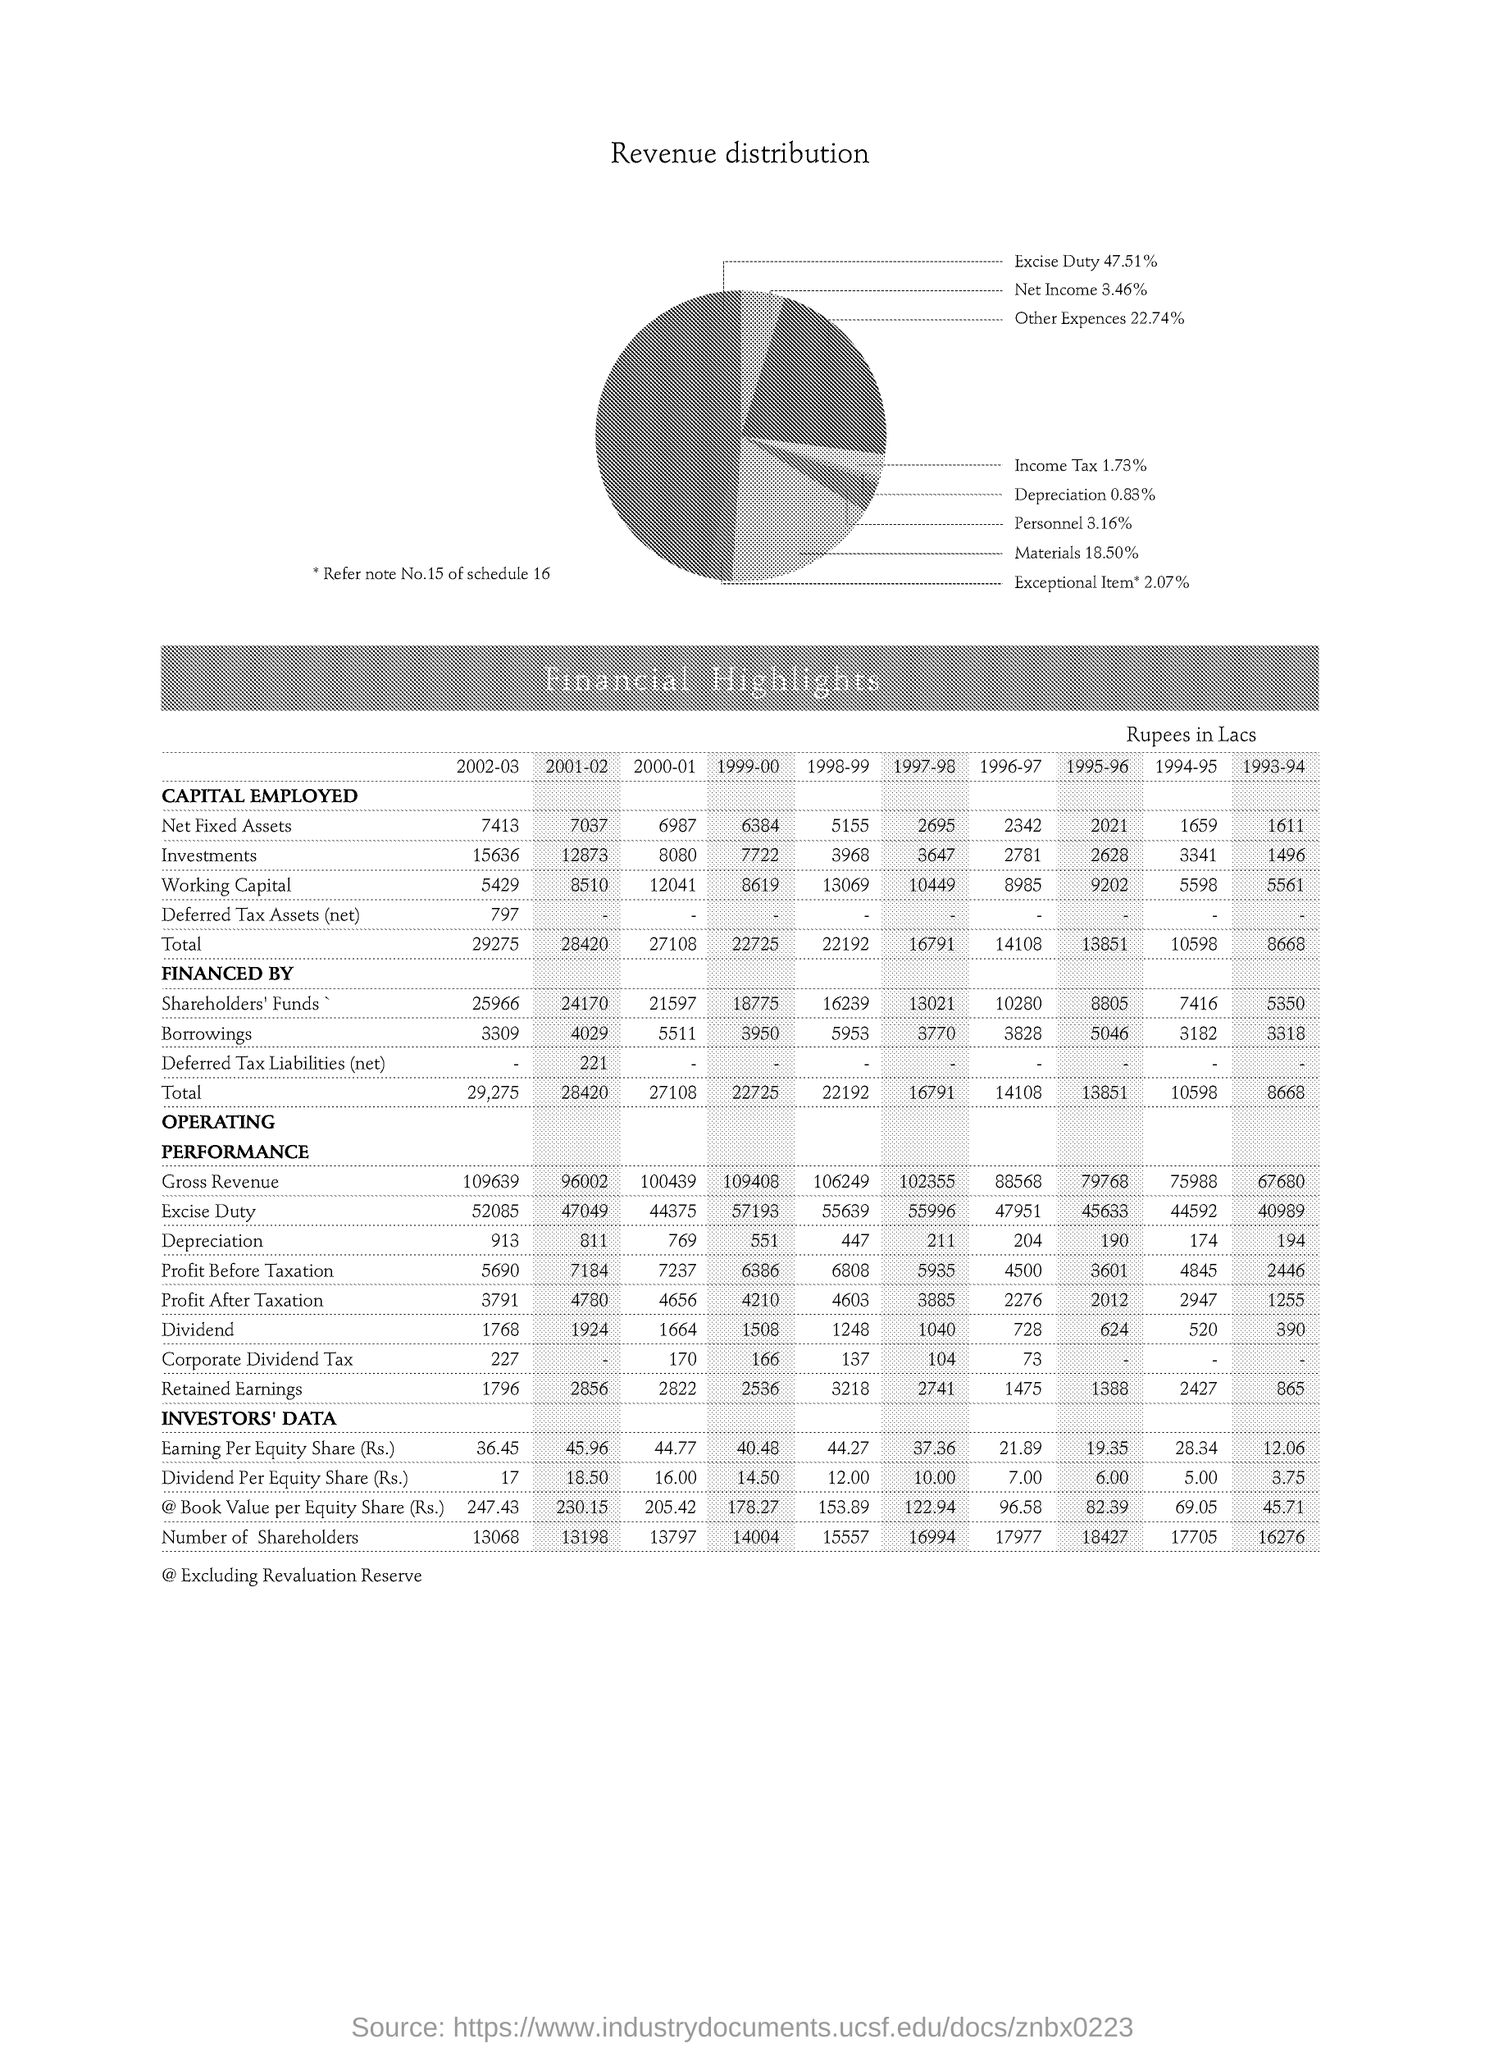What is the % of Net Income ?
Provide a succinct answer. 3.46%. What is the % of Materials ?
Keep it short and to the point. 18.50%. What is the amount of Investments in 1997-98 ?
Offer a very short reply. 3647. How much amount of Borrowings in 2002-03 ?
Your response must be concise. 3309. How much Smallest amount in 2001-02 ?
Provide a succinct answer. 18.50. What is the % of Other Expenses ?
Give a very brief answer. 22.74%. 